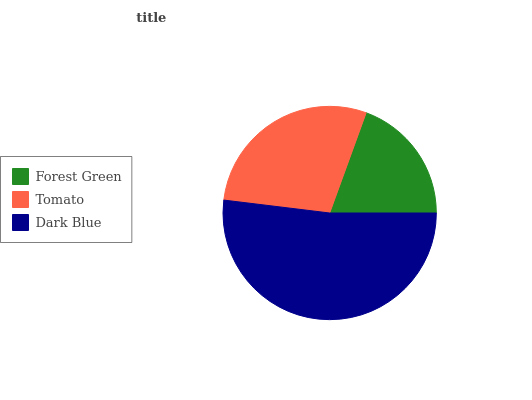Is Forest Green the minimum?
Answer yes or no. Yes. Is Dark Blue the maximum?
Answer yes or no. Yes. Is Tomato the minimum?
Answer yes or no. No. Is Tomato the maximum?
Answer yes or no. No. Is Tomato greater than Forest Green?
Answer yes or no. Yes. Is Forest Green less than Tomato?
Answer yes or no. Yes. Is Forest Green greater than Tomato?
Answer yes or no. No. Is Tomato less than Forest Green?
Answer yes or no. No. Is Tomato the high median?
Answer yes or no. Yes. Is Tomato the low median?
Answer yes or no. Yes. Is Dark Blue the high median?
Answer yes or no. No. Is Forest Green the low median?
Answer yes or no. No. 